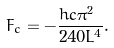<formula> <loc_0><loc_0><loc_500><loc_500>F _ { c } = - \frac { \hbar { c } \pi ^ { 2 } } { 2 4 0 L ^ { 4 } } .</formula> 